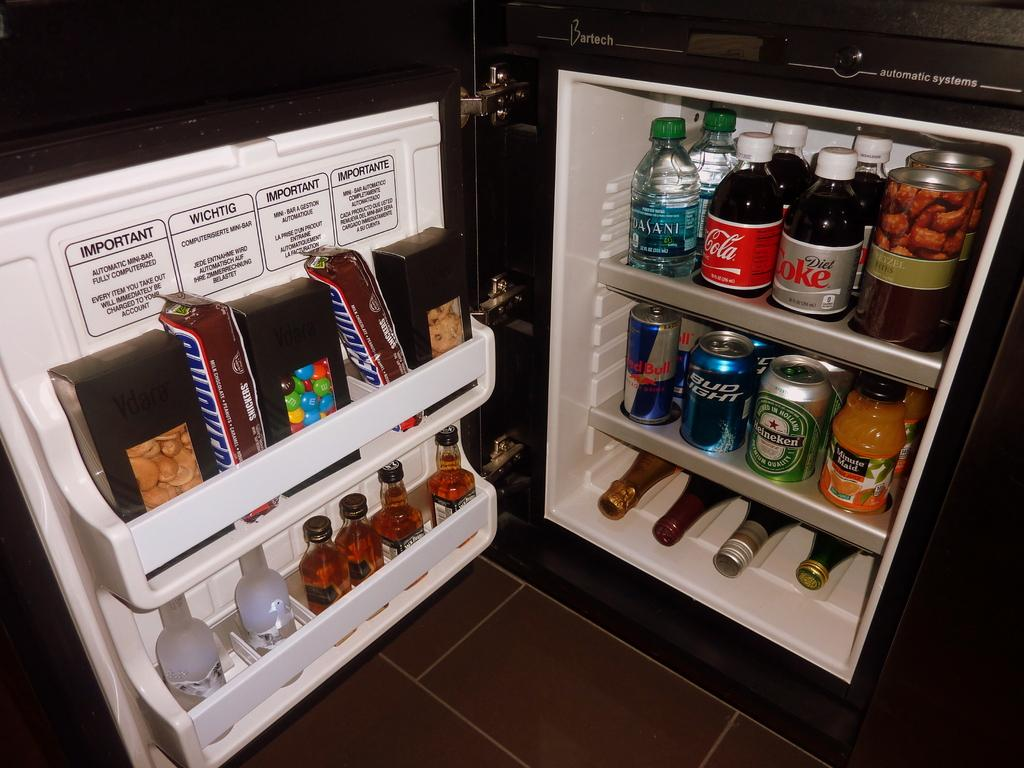<image>
Give a short and clear explanation of the subsequent image. A fridge full of food and beverages like Diet Coke. 